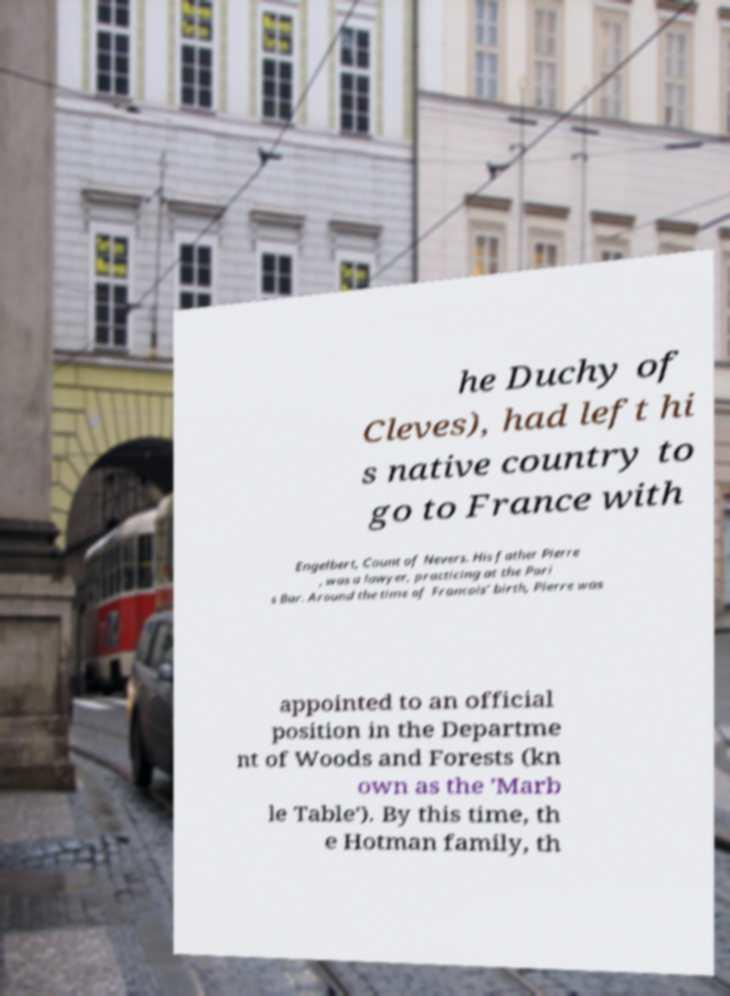Please identify and transcribe the text found in this image. he Duchy of Cleves), had left hi s native country to go to France with Engelbert, Count of Nevers. His father Pierre , was a lawyer, practicing at the Pari s Bar. Around the time of Francois' birth, Pierre was appointed to an official position in the Departme nt of Woods and Forests (kn own as the 'Marb le Table'). By this time, th e Hotman family, th 